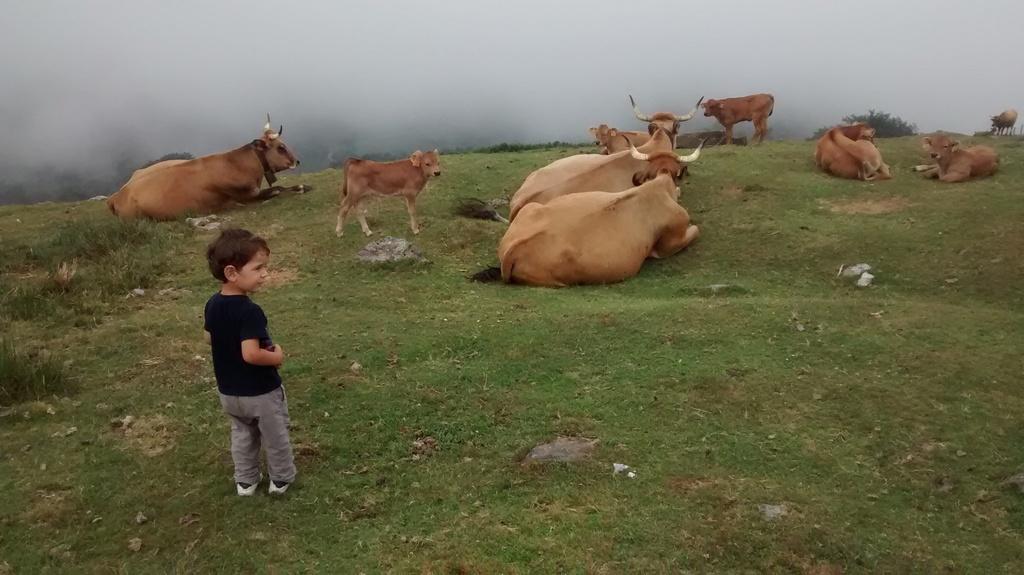Describe this image in one or two sentences. In this image I can see the person with black and grey color dress. To the side of the person I can see many animals which are in brown color. These are on the ground. To the left I can see some grass. In the background I can see the fog. 